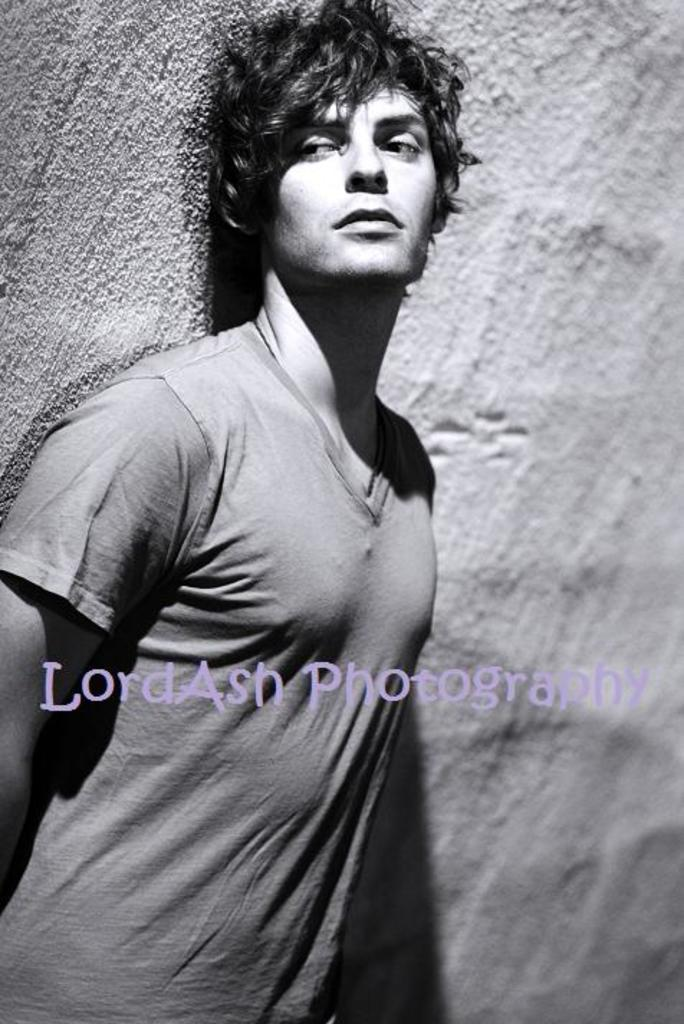Who is present in the image? There is a man in the image. What is the man wearing? The man is wearing a t-shirt. Where is the man standing? The man is standing in front of a wall. What is the color scheme of the image? The image is black and white. What type of stitch is the man using to sew a band in the image? There is no band or stitching activity present in the image. 